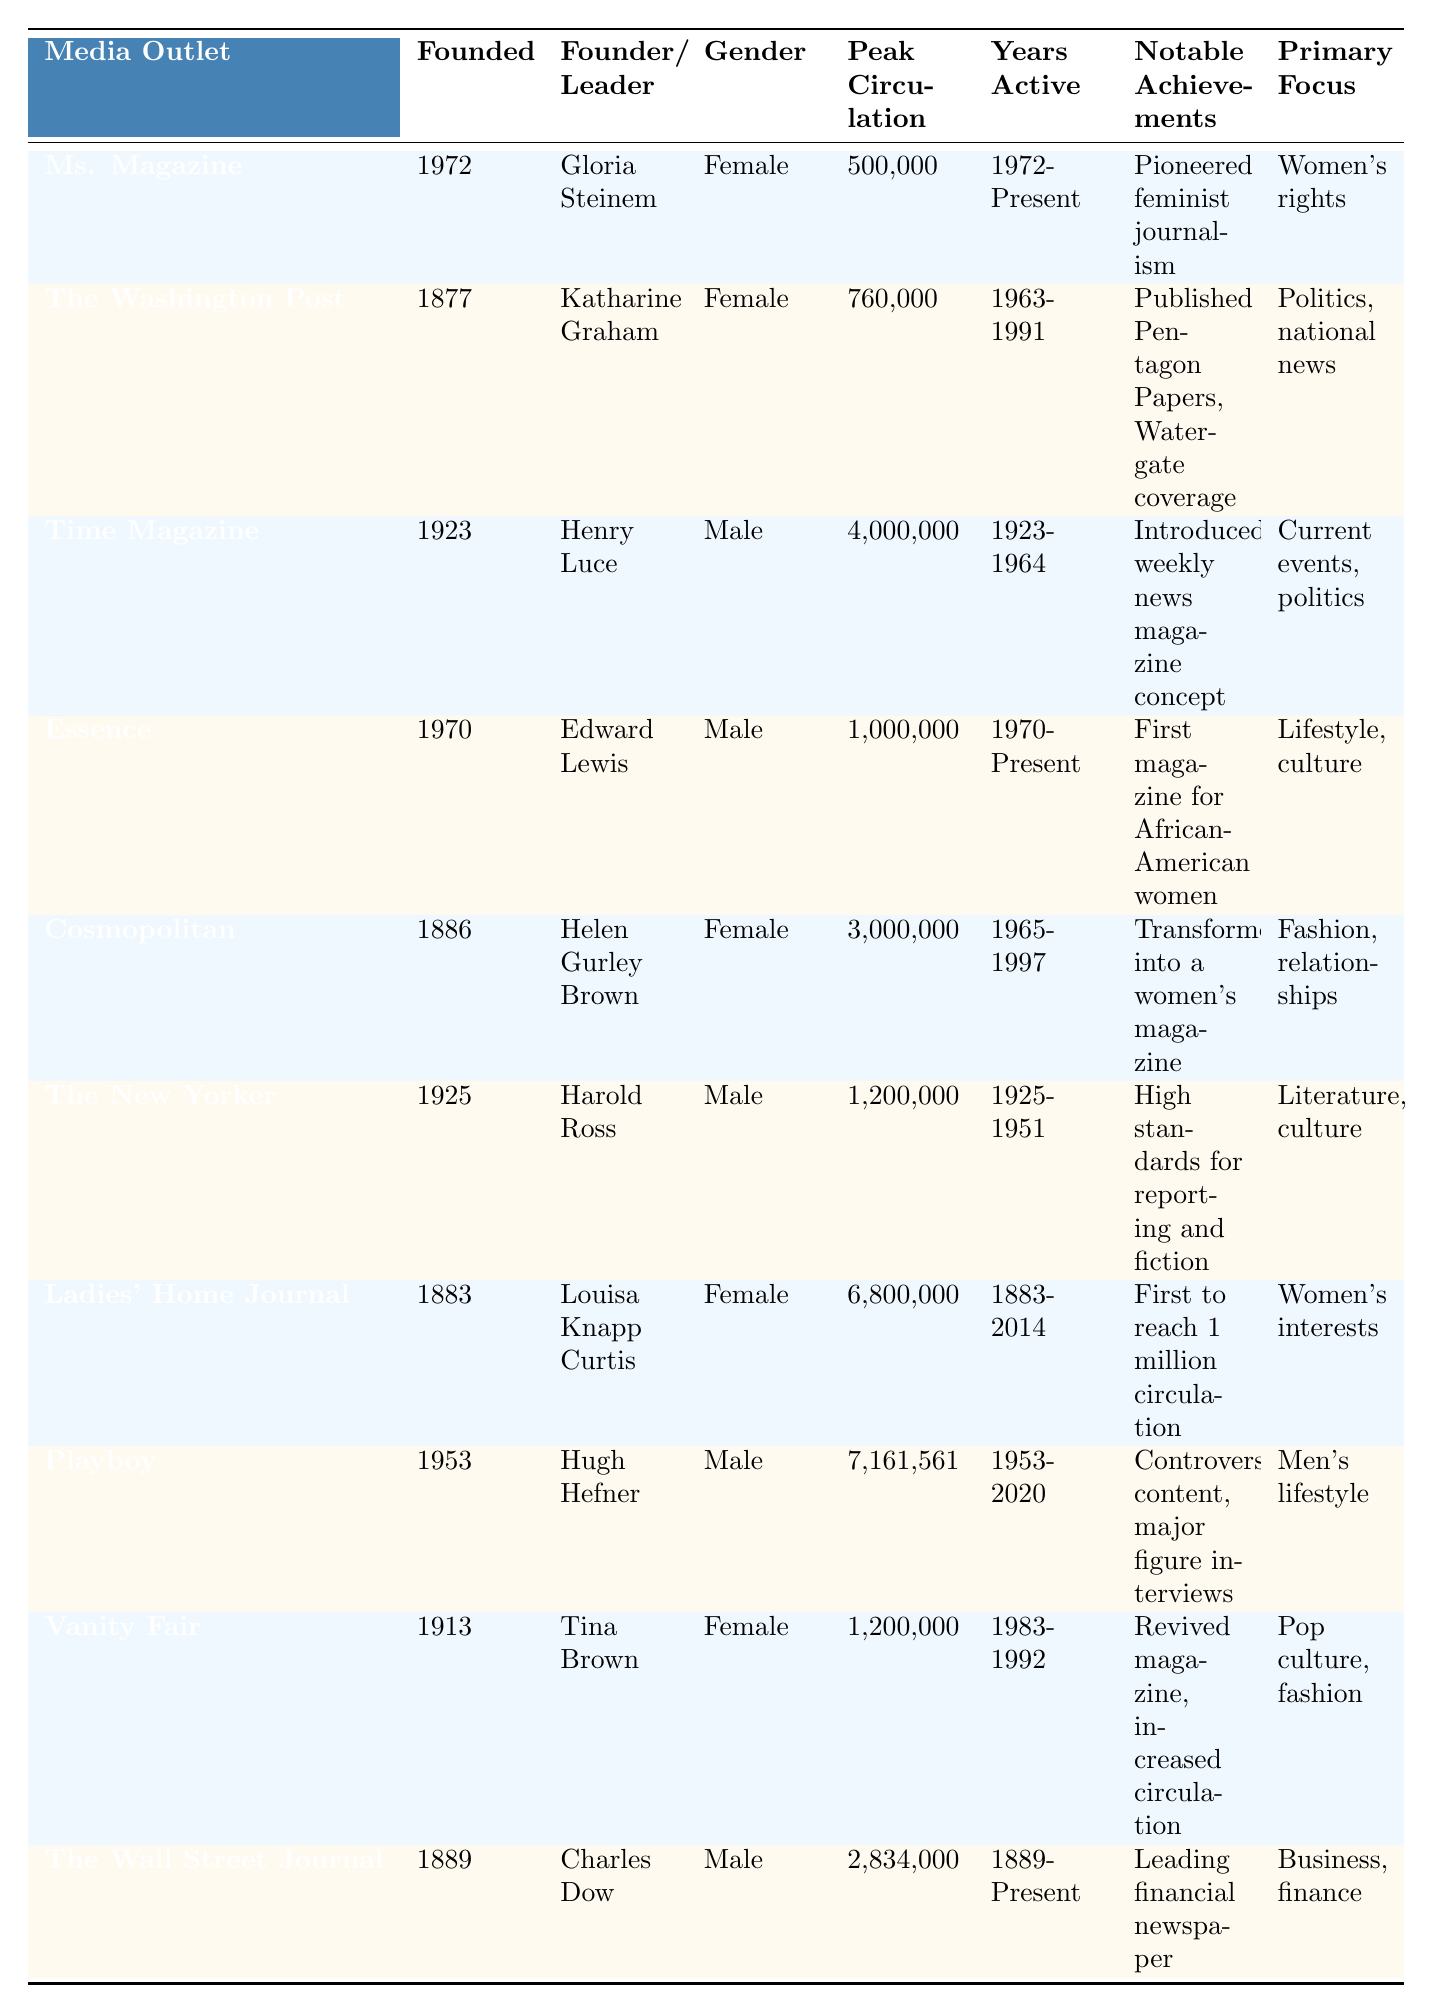What is the peak circulation of Ms. Magazine? The table shows that Ms. Magazine has a peak circulation of 500,000.
Answer: 500,000 Who founded The Washington Post? According to the table, The Washington Post was founded by Katharine Graham.
Answer: Katharine Graham How many years was Cosmopolitan active? Cosmopolitan was active from 1965 to 1997, which is a total of 32 years (1997 - 1965).
Answer: 32 years Which media outlet had the highest peak circulation? By comparing the peak circulation values, Ladies' Home Journal has the highest peak circulation at 6,800,000.
Answer: Ladies' Home Journal Is Essence a female-led media outlet? Essence was founded by Edward Lewis, who is male, so it is not female-led.
Answer: No What is the gender of the founder of Vanity Fair? The table indicates that Vanity Fair was founded by Tina Brown, who is female.
Answer: Female What is the difference in peak circulation between Playboy and Time Magazine? Playboy's peak circulation is 7,161,561, and Time Magazine's peak circulation is 4,000,000. The difference is 7,161,561 - 4,000,000 = 3,161,561.
Answer: 3,161,561 Which female-led media outlet has the highest peak circulation among the listed outlets? Ladies' Home Journal has the highest peak circulation at 6,800,000, making it the top female-led outlet.
Answer: Ladies' Home Journal Calculate the average peak circulation of male-led media outlets. Adding the peak circulations of male-led outlets: 4,000,000 (Time) + 1,000,000 (Essence) + 1,200,000 (The New Yorker) + 7,161,561 (Playboy) + 2,834,000 (The Wall Street Journal) gives 16,195,561. There are 5 male-led outlets, so the average is 16,195,561 / 5 = 3,239,112.2.
Answer: 3,239,112.2 Did any female-led media outlets focus primarily on women's rights? The table notes that Ms. Magazine focuses on women's rights, confirming that there is at least one female-led outlet focusing on this area.
Answer: Yes Which media outlet was first to reach a significant milestone in circulation, and what was that milestone? Ladies' Home Journal was the first to reach a circulation of 1 million, as noted in the achievements section.
Answer: 1 million 